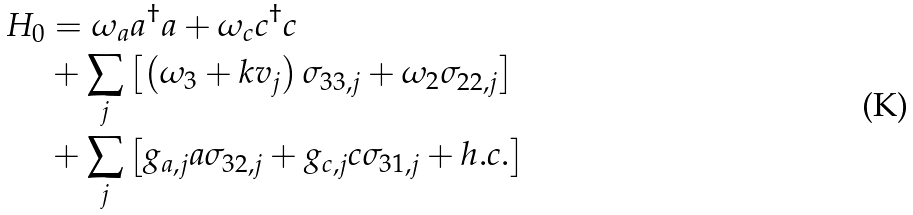<formula> <loc_0><loc_0><loc_500><loc_500>H _ { 0 } & = \omega _ { a } a ^ { \dagger } a + \omega _ { c } c ^ { \dagger } c \\ & + \sum _ { j } \left [ \left ( \omega _ { 3 } + k v _ { j } \right ) \sigma _ { 3 3 , j } + \omega _ { 2 } \sigma _ { 2 2 , j } \right ] \\ & + \sum _ { j } \left [ g _ { a , j } a \sigma _ { 3 2 , j } + g _ { c , j } c \sigma _ { 3 1 , j } + h . c . \right ]</formula> 